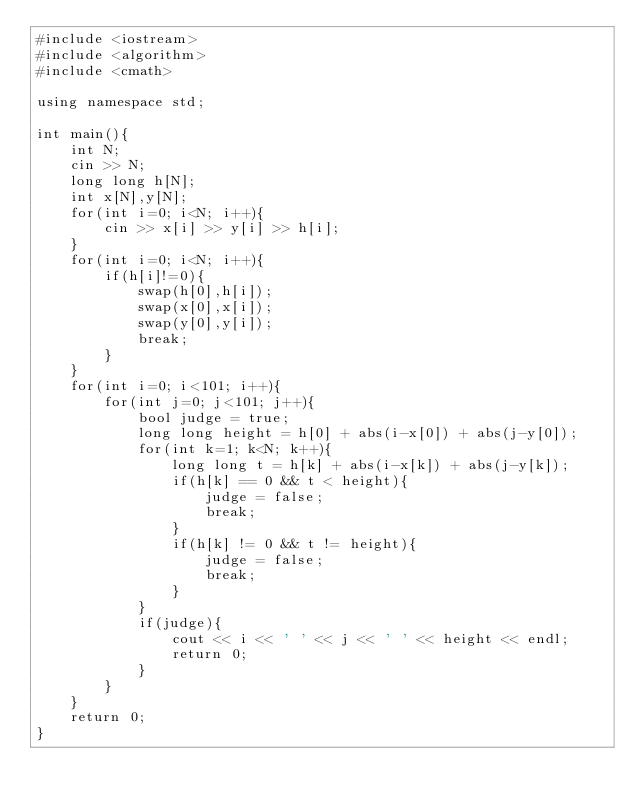Convert code to text. <code><loc_0><loc_0><loc_500><loc_500><_C++_>#include <iostream>
#include <algorithm>
#include <cmath>

using namespace std;

int main(){
    int N;
    cin >> N;
    long long h[N];
    int x[N],y[N];
    for(int i=0; i<N; i++){
        cin >> x[i] >> y[i] >> h[i];
    }
    for(int i=0; i<N; i++){
        if(h[i]!=0){
            swap(h[0],h[i]);
            swap(x[0],x[i]);
            swap(y[0],y[i]);
            break;
        }
    }
    for(int i=0; i<101; i++){
        for(int j=0; j<101; j++){
            bool judge = true;
            long long height = h[0] + abs(i-x[0]) + abs(j-y[0]);
            for(int k=1; k<N; k++){
                long long t = h[k] + abs(i-x[k]) + abs(j-y[k]);
                if(h[k] == 0 && t < height){
                    judge = false;
                    break;
                }
                if(h[k] != 0 && t != height){
                    judge = false;
                    break;
                }
            }
            if(judge){
                cout << i << ' ' << j << ' ' << height << endl;
                return 0;
            }
        }
    }
    return 0;
}
</code> 